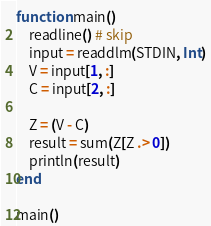<code> <loc_0><loc_0><loc_500><loc_500><_Julia_>function main()
    readline() # skip
    input = readdlm(STDIN, Int)
    V = input[1, :]
    C = input[2, :]

    Z = (V - C)
    result = sum(Z[Z .> 0])
    println(result)
end

main()</code> 